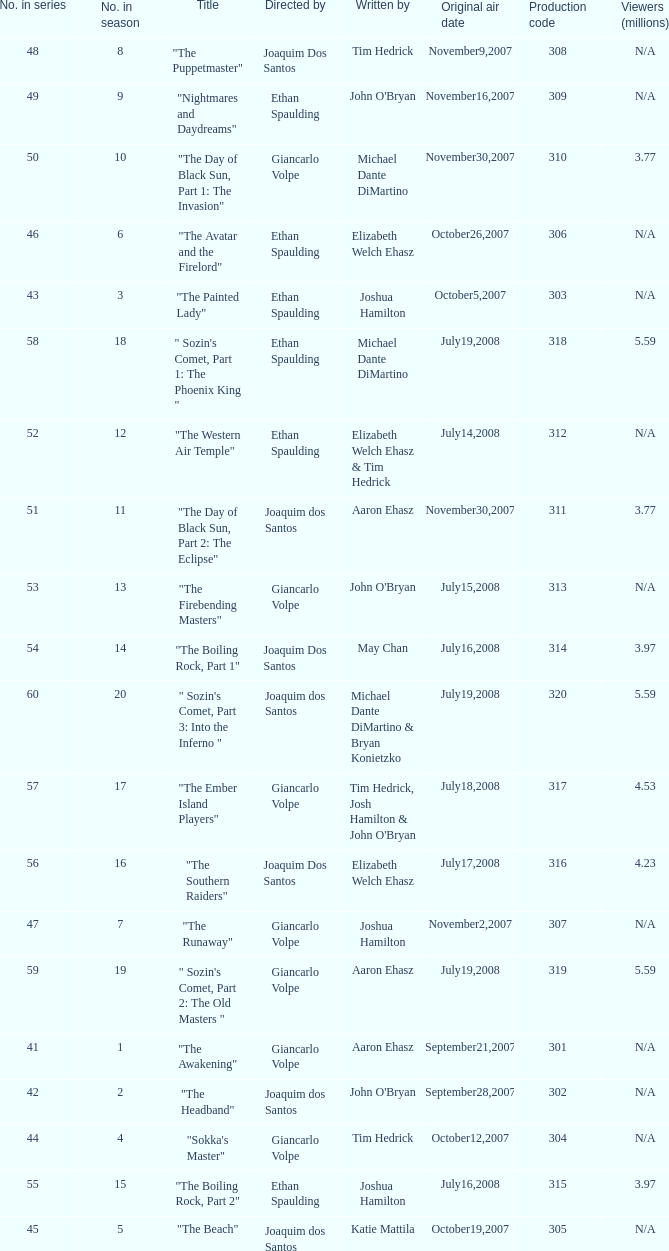What are all the numbers in the series with an episode title of "the beach"? 45.0. 